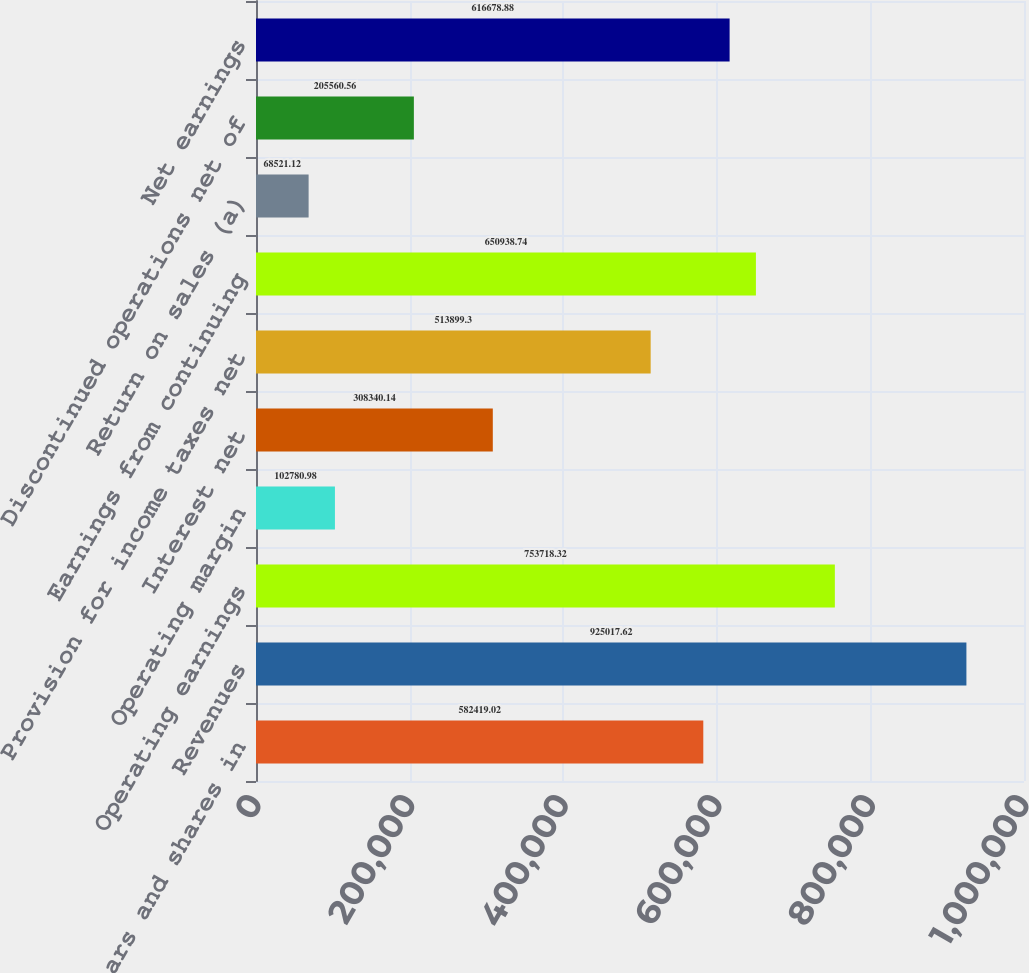Convert chart. <chart><loc_0><loc_0><loc_500><loc_500><bar_chart><fcel>(Dollars and shares in<fcel>Revenues<fcel>Operating earnings<fcel>Operating margin<fcel>Interest net<fcel>Provision for income taxes net<fcel>Earnings from continuing<fcel>Return on sales (a)<fcel>Discontinued operations net of<fcel>Net earnings<nl><fcel>582419<fcel>925018<fcel>753718<fcel>102781<fcel>308340<fcel>513899<fcel>650939<fcel>68521.1<fcel>205561<fcel>616679<nl></chart> 